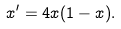<formula> <loc_0><loc_0><loc_500><loc_500>x ^ { \prime } = 4 x ( 1 - x ) .</formula> 